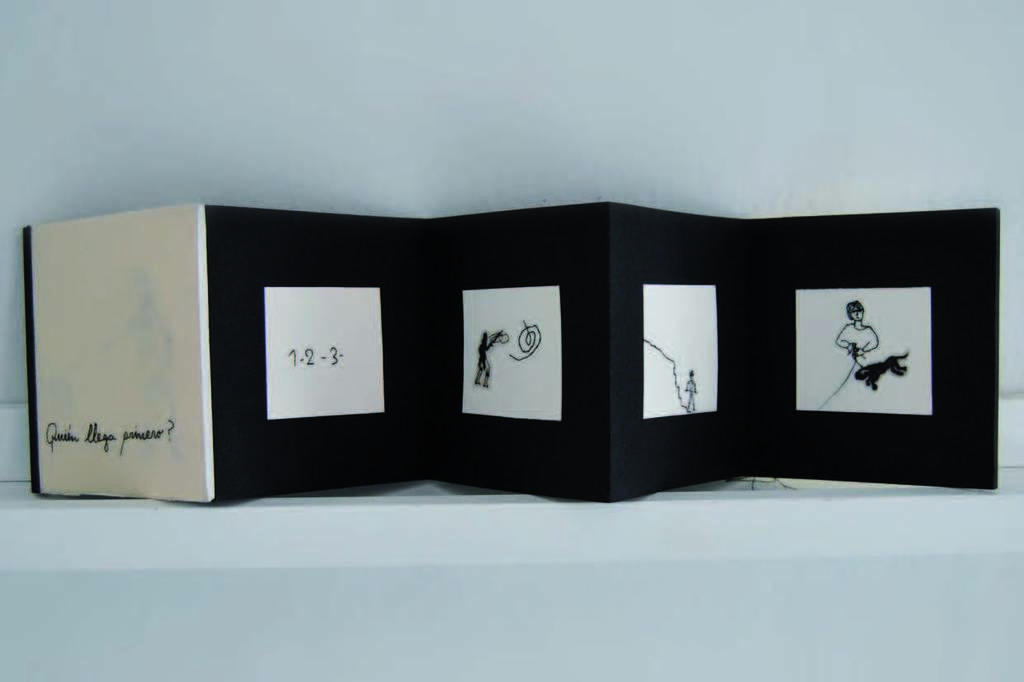How would you summarize this image in a sentence or two? In this image I can see the board which is in black and white color. In the background I can see the white wall. 